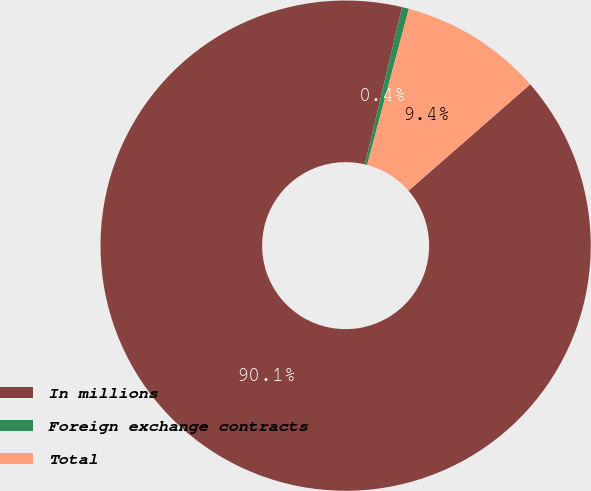Convert chart to OTSL. <chart><loc_0><loc_0><loc_500><loc_500><pie_chart><fcel>In millions<fcel>Foreign exchange contracts<fcel>Total<nl><fcel>90.14%<fcel>0.45%<fcel>9.42%<nl></chart> 